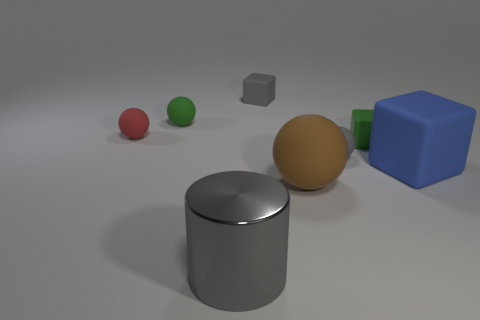There is a gray matte object that is behind the green rubber block; is its size the same as the large ball?
Your response must be concise. No. There is a rubber ball that is the same color as the big metallic thing; what size is it?
Keep it short and to the point. Small. Are there any cyan matte objects that have the same size as the green matte block?
Offer a very short reply. No. There is a rubber ball to the left of the small green sphere; does it have the same color as the tiny ball that is to the right of the metallic object?
Your response must be concise. No. Is there a small rubber sphere that has the same color as the large matte cube?
Your response must be concise. No. What number of other objects are the same shape as the brown rubber thing?
Your answer should be very brief. 3. What is the shape of the rubber object in front of the big rubber cube?
Make the answer very short. Sphere. Do the small red thing and the tiny gray object that is on the right side of the large ball have the same shape?
Your answer should be very brief. Yes. How big is the thing that is right of the large metal object and behind the red matte object?
Your answer should be compact. Small. What color is the big object that is left of the green rubber block and behind the cylinder?
Make the answer very short. Brown. 